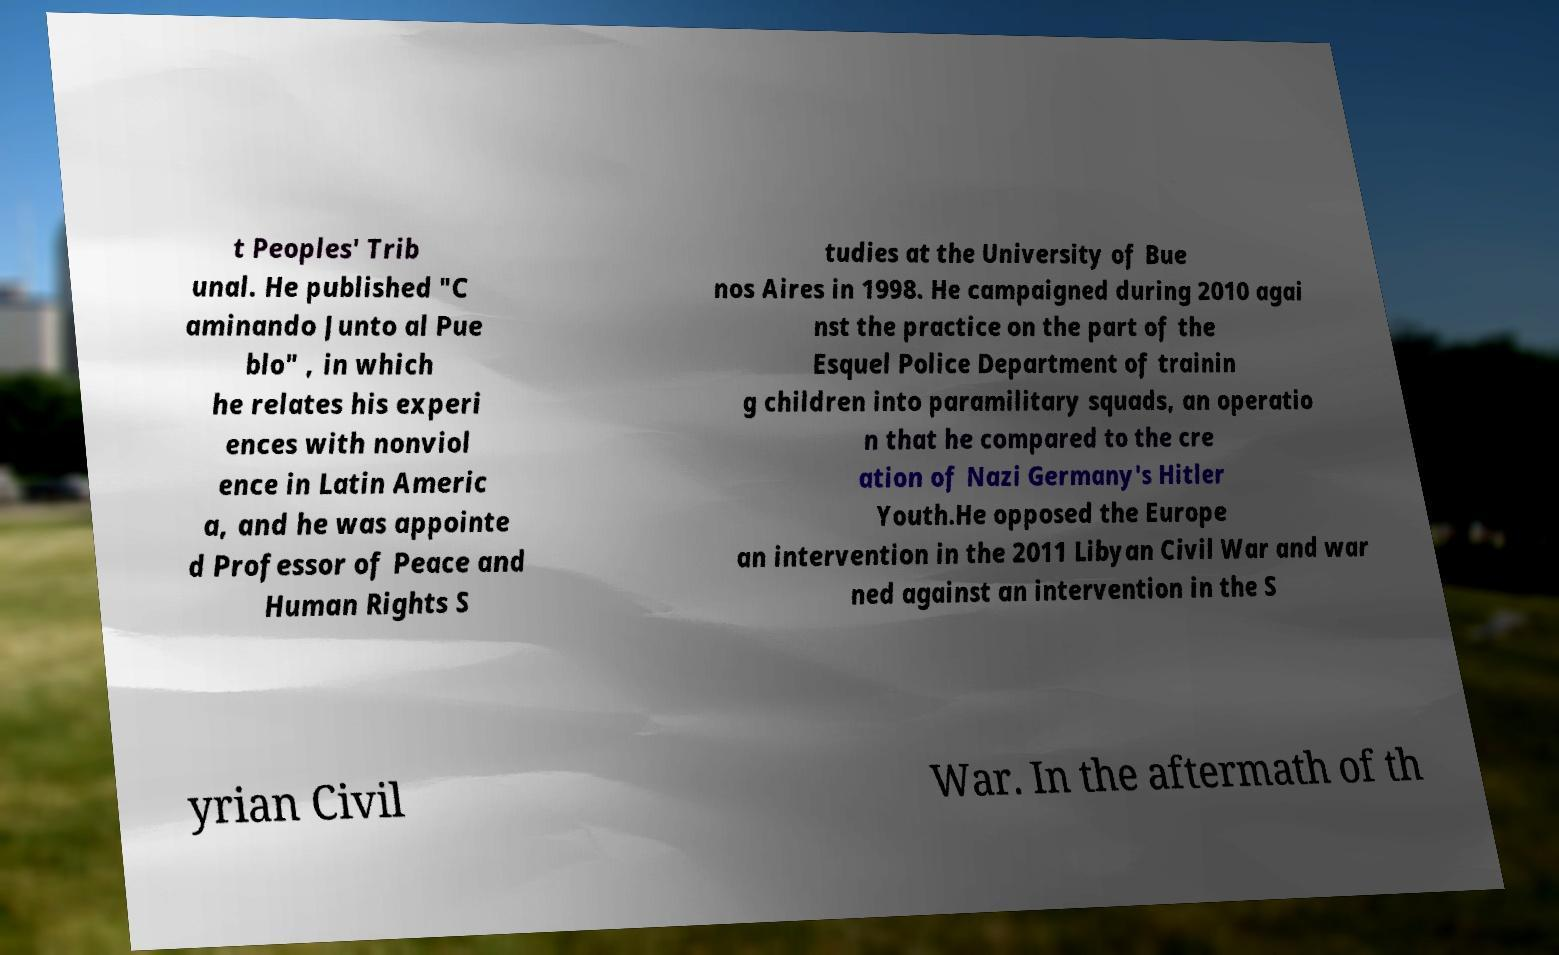Please read and relay the text visible in this image. What does it say? t Peoples' Trib unal. He published "C aminando Junto al Pue blo" , in which he relates his experi ences with nonviol ence in Latin Americ a, and he was appointe d Professor of Peace and Human Rights S tudies at the University of Bue nos Aires in 1998. He campaigned during 2010 agai nst the practice on the part of the Esquel Police Department of trainin g children into paramilitary squads, an operatio n that he compared to the cre ation of Nazi Germany's Hitler Youth.He opposed the Europe an intervention in the 2011 Libyan Civil War and war ned against an intervention in the S yrian Civil War. In the aftermath of th 